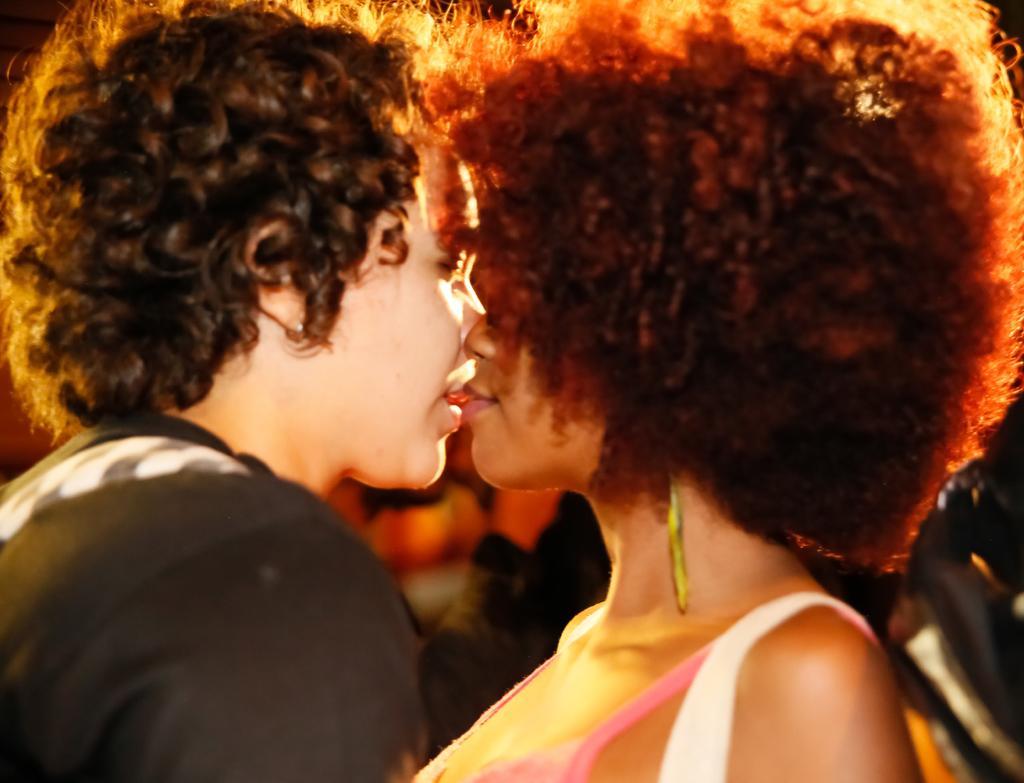Describe this image in one or two sentences. This image consists of two persons. They are women. 